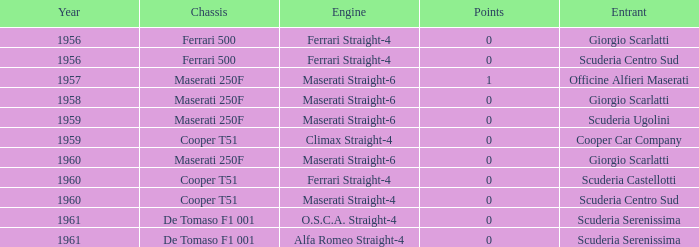How many points for the cooper car company after 1959? None. 